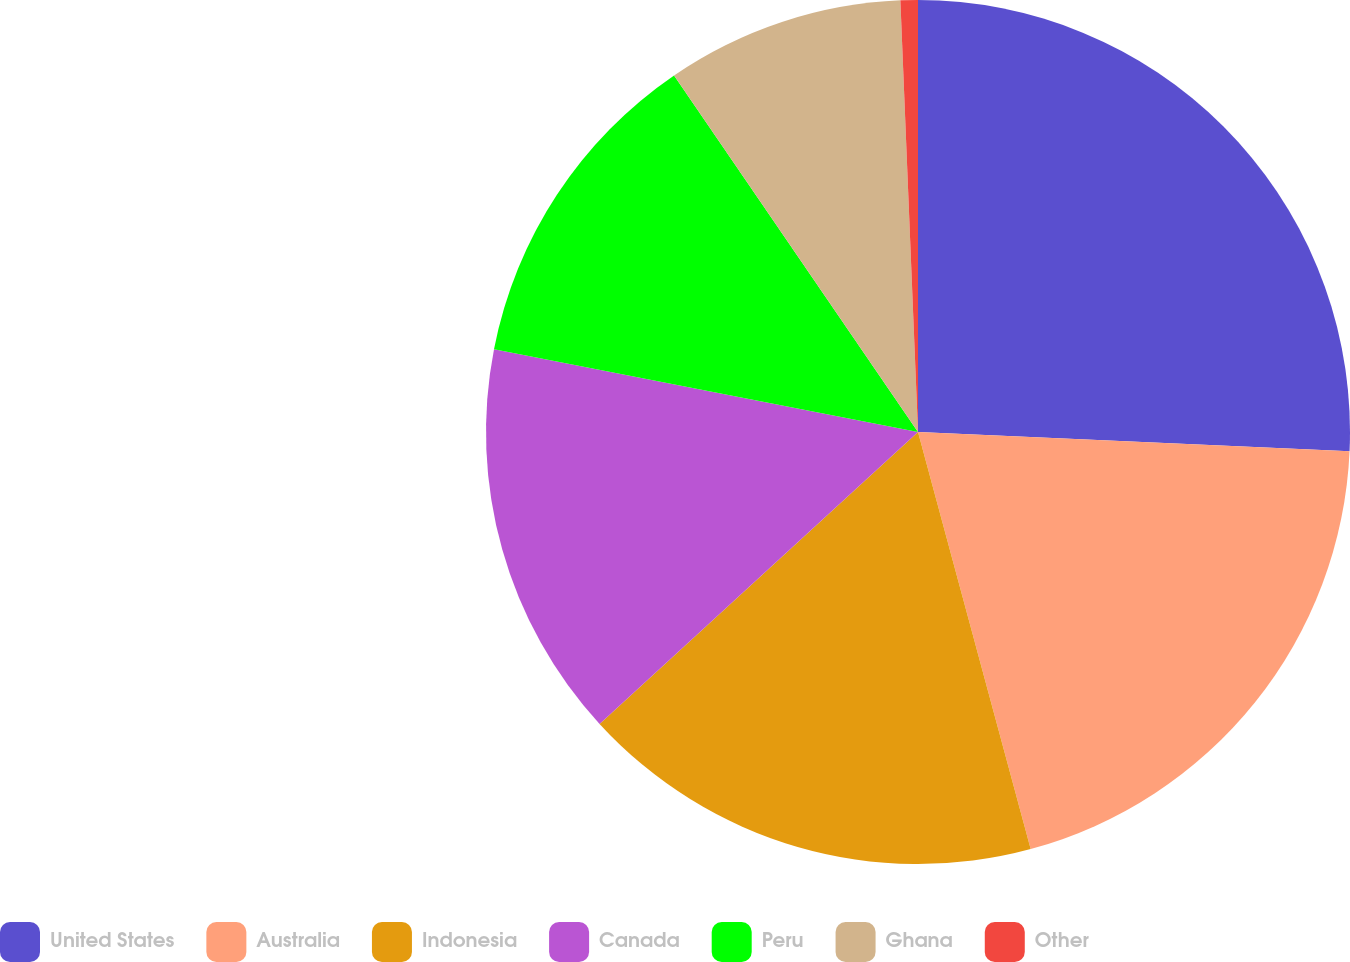Convert chart. <chart><loc_0><loc_0><loc_500><loc_500><pie_chart><fcel>United States<fcel>Australia<fcel>Indonesia<fcel>Canada<fcel>Peru<fcel>Ghana<fcel>Other<nl><fcel>25.71%<fcel>20.09%<fcel>17.39%<fcel>14.88%<fcel>12.38%<fcel>8.9%<fcel>0.65%<nl></chart> 